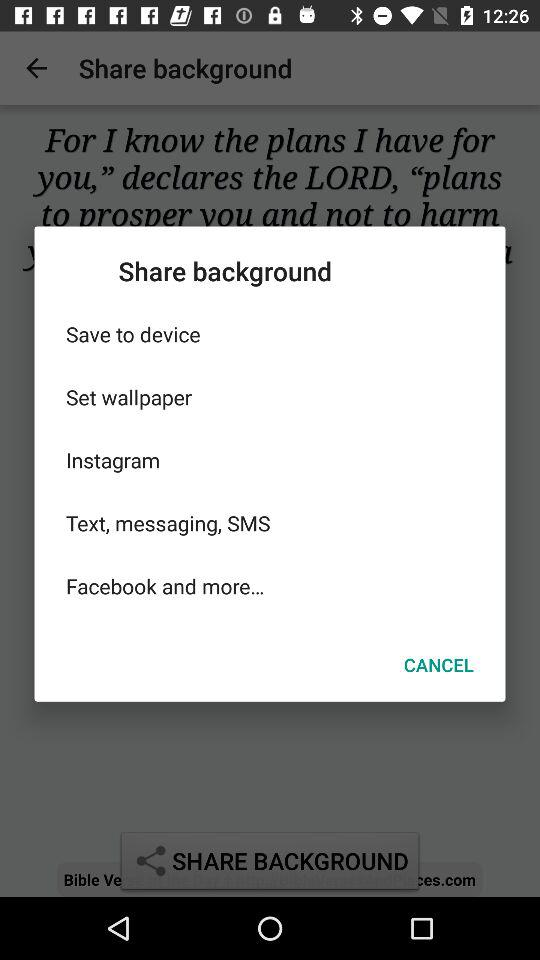What are the options available for "Share background"? The available options are "Save to device", "Set wallpaper", "Instagram", "Text, messaging, SMS" and "Facebook". 